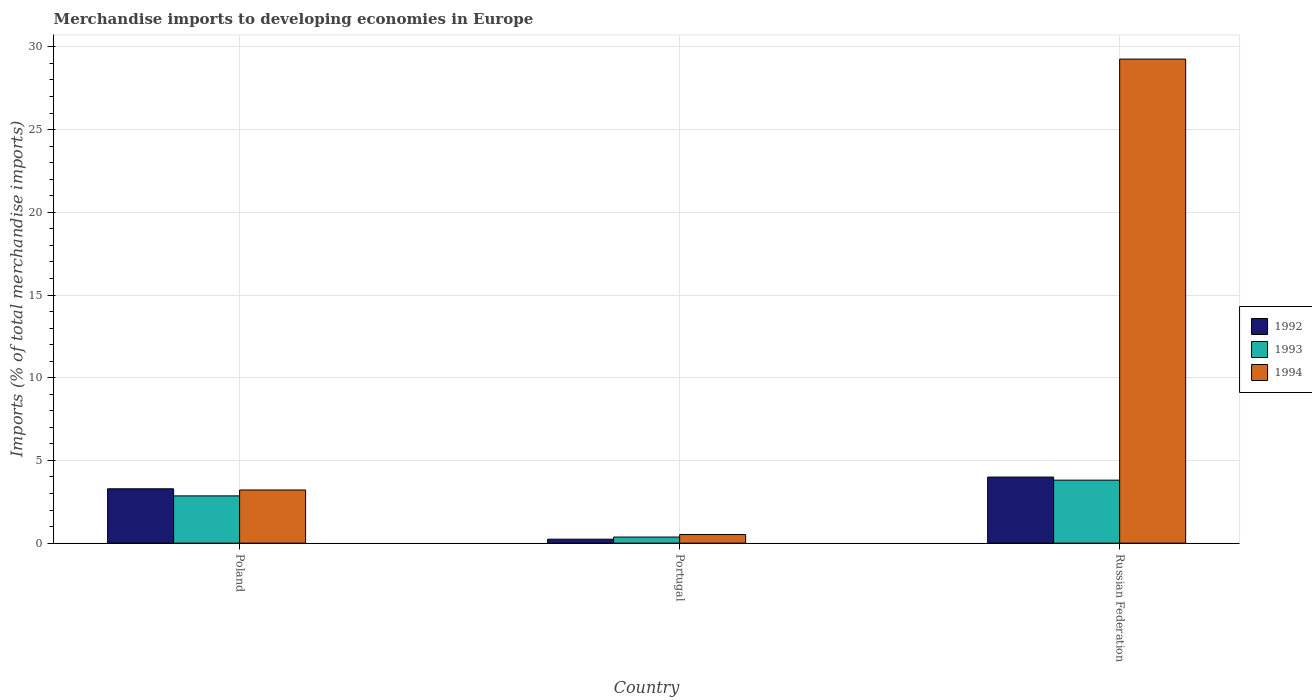How many groups of bars are there?
Give a very brief answer. 3. Are the number of bars per tick equal to the number of legend labels?
Provide a short and direct response. Yes. What is the percentage total merchandise imports in 1993 in Portugal?
Make the answer very short. 0.37. Across all countries, what is the maximum percentage total merchandise imports in 1992?
Your answer should be very brief. 4. Across all countries, what is the minimum percentage total merchandise imports in 1993?
Your answer should be very brief. 0.37. In which country was the percentage total merchandise imports in 1994 maximum?
Ensure brevity in your answer.  Russian Federation. In which country was the percentage total merchandise imports in 1992 minimum?
Make the answer very short. Portugal. What is the total percentage total merchandise imports in 1993 in the graph?
Your answer should be compact. 7.03. What is the difference between the percentage total merchandise imports in 1994 in Portugal and that in Russian Federation?
Your response must be concise. -28.74. What is the difference between the percentage total merchandise imports in 1993 in Poland and the percentage total merchandise imports in 1994 in Portugal?
Your answer should be very brief. 2.34. What is the average percentage total merchandise imports in 1994 per country?
Make the answer very short. 11. What is the difference between the percentage total merchandise imports of/in 1993 and percentage total merchandise imports of/in 1994 in Portugal?
Ensure brevity in your answer.  -0.15. In how many countries, is the percentage total merchandise imports in 1993 greater than 1 %?
Offer a terse response. 2. What is the ratio of the percentage total merchandise imports in 1992 in Portugal to that in Russian Federation?
Provide a succinct answer. 0.06. Is the difference between the percentage total merchandise imports in 1993 in Poland and Portugal greater than the difference between the percentage total merchandise imports in 1994 in Poland and Portugal?
Offer a terse response. No. What is the difference between the highest and the second highest percentage total merchandise imports in 1992?
Your answer should be very brief. -0.71. What is the difference between the highest and the lowest percentage total merchandise imports in 1992?
Your answer should be very brief. 3.76. Is the sum of the percentage total merchandise imports in 1994 in Poland and Portugal greater than the maximum percentage total merchandise imports in 1993 across all countries?
Your answer should be very brief. No. What does the 2nd bar from the right in Portugal represents?
Keep it short and to the point. 1993. Does the graph contain grids?
Offer a very short reply. Yes. How many legend labels are there?
Make the answer very short. 3. What is the title of the graph?
Your answer should be very brief. Merchandise imports to developing economies in Europe. What is the label or title of the X-axis?
Offer a terse response. Country. What is the label or title of the Y-axis?
Your answer should be very brief. Imports (% of total merchandise imports). What is the Imports (% of total merchandise imports) of 1992 in Poland?
Offer a terse response. 3.29. What is the Imports (% of total merchandise imports) in 1993 in Poland?
Ensure brevity in your answer.  2.86. What is the Imports (% of total merchandise imports) of 1994 in Poland?
Offer a terse response. 3.21. What is the Imports (% of total merchandise imports) in 1992 in Portugal?
Provide a short and direct response. 0.24. What is the Imports (% of total merchandise imports) of 1993 in Portugal?
Offer a terse response. 0.37. What is the Imports (% of total merchandise imports) of 1994 in Portugal?
Your response must be concise. 0.52. What is the Imports (% of total merchandise imports) in 1992 in Russian Federation?
Provide a succinct answer. 4. What is the Imports (% of total merchandise imports) of 1993 in Russian Federation?
Ensure brevity in your answer.  3.81. What is the Imports (% of total merchandise imports) of 1994 in Russian Federation?
Provide a succinct answer. 29.26. Across all countries, what is the maximum Imports (% of total merchandise imports) in 1992?
Provide a short and direct response. 4. Across all countries, what is the maximum Imports (% of total merchandise imports) in 1993?
Your answer should be very brief. 3.81. Across all countries, what is the maximum Imports (% of total merchandise imports) of 1994?
Give a very brief answer. 29.26. Across all countries, what is the minimum Imports (% of total merchandise imports) in 1992?
Offer a terse response. 0.24. Across all countries, what is the minimum Imports (% of total merchandise imports) in 1993?
Provide a succinct answer. 0.37. Across all countries, what is the minimum Imports (% of total merchandise imports) of 1994?
Make the answer very short. 0.52. What is the total Imports (% of total merchandise imports) in 1992 in the graph?
Give a very brief answer. 7.52. What is the total Imports (% of total merchandise imports) of 1993 in the graph?
Offer a very short reply. 7.03. What is the total Imports (% of total merchandise imports) in 1994 in the graph?
Provide a short and direct response. 33. What is the difference between the Imports (% of total merchandise imports) of 1992 in Poland and that in Portugal?
Provide a succinct answer. 3.05. What is the difference between the Imports (% of total merchandise imports) of 1993 in Poland and that in Portugal?
Give a very brief answer. 2.49. What is the difference between the Imports (% of total merchandise imports) in 1994 in Poland and that in Portugal?
Provide a succinct answer. 2.69. What is the difference between the Imports (% of total merchandise imports) of 1992 in Poland and that in Russian Federation?
Give a very brief answer. -0.71. What is the difference between the Imports (% of total merchandise imports) in 1993 in Poland and that in Russian Federation?
Your response must be concise. -0.95. What is the difference between the Imports (% of total merchandise imports) of 1994 in Poland and that in Russian Federation?
Make the answer very short. -26.05. What is the difference between the Imports (% of total merchandise imports) of 1992 in Portugal and that in Russian Federation?
Keep it short and to the point. -3.76. What is the difference between the Imports (% of total merchandise imports) in 1993 in Portugal and that in Russian Federation?
Keep it short and to the point. -3.44. What is the difference between the Imports (% of total merchandise imports) in 1994 in Portugal and that in Russian Federation?
Ensure brevity in your answer.  -28.74. What is the difference between the Imports (% of total merchandise imports) in 1992 in Poland and the Imports (% of total merchandise imports) in 1993 in Portugal?
Offer a terse response. 2.92. What is the difference between the Imports (% of total merchandise imports) in 1992 in Poland and the Imports (% of total merchandise imports) in 1994 in Portugal?
Your answer should be compact. 2.77. What is the difference between the Imports (% of total merchandise imports) of 1993 in Poland and the Imports (% of total merchandise imports) of 1994 in Portugal?
Offer a terse response. 2.34. What is the difference between the Imports (% of total merchandise imports) in 1992 in Poland and the Imports (% of total merchandise imports) in 1993 in Russian Federation?
Make the answer very short. -0.52. What is the difference between the Imports (% of total merchandise imports) of 1992 in Poland and the Imports (% of total merchandise imports) of 1994 in Russian Federation?
Offer a terse response. -25.98. What is the difference between the Imports (% of total merchandise imports) of 1993 in Poland and the Imports (% of total merchandise imports) of 1994 in Russian Federation?
Provide a short and direct response. -26.41. What is the difference between the Imports (% of total merchandise imports) of 1992 in Portugal and the Imports (% of total merchandise imports) of 1993 in Russian Federation?
Your answer should be compact. -3.57. What is the difference between the Imports (% of total merchandise imports) in 1992 in Portugal and the Imports (% of total merchandise imports) in 1994 in Russian Federation?
Offer a very short reply. -29.03. What is the difference between the Imports (% of total merchandise imports) of 1993 in Portugal and the Imports (% of total merchandise imports) of 1994 in Russian Federation?
Make the answer very short. -28.9. What is the average Imports (% of total merchandise imports) of 1992 per country?
Offer a very short reply. 2.51. What is the average Imports (% of total merchandise imports) of 1993 per country?
Offer a terse response. 2.34. What is the average Imports (% of total merchandise imports) of 1994 per country?
Provide a short and direct response. 11. What is the difference between the Imports (% of total merchandise imports) of 1992 and Imports (% of total merchandise imports) of 1993 in Poland?
Your response must be concise. 0.43. What is the difference between the Imports (% of total merchandise imports) of 1992 and Imports (% of total merchandise imports) of 1994 in Poland?
Provide a succinct answer. 0.07. What is the difference between the Imports (% of total merchandise imports) in 1993 and Imports (% of total merchandise imports) in 1994 in Poland?
Provide a short and direct response. -0.36. What is the difference between the Imports (% of total merchandise imports) of 1992 and Imports (% of total merchandise imports) of 1993 in Portugal?
Your answer should be very brief. -0.13. What is the difference between the Imports (% of total merchandise imports) of 1992 and Imports (% of total merchandise imports) of 1994 in Portugal?
Your answer should be compact. -0.28. What is the difference between the Imports (% of total merchandise imports) in 1993 and Imports (% of total merchandise imports) in 1994 in Portugal?
Ensure brevity in your answer.  -0.15. What is the difference between the Imports (% of total merchandise imports) in 1992 and Imports (% of total merchandise imports) in 1993 in Russian Federation?
Provide a succinct answer. 0.19. What is the difference between the Imports (% of total merchandise imports) of 1992 and Imports (% of total merchandise imports) of 1994 in Russian Federation?
Offer a terse response. -25.27. What is the difference between the Imports (% of total merchandise imports) of 1993 and Imports (% of total merchandise imports) of 1994 in Russian Federation?
Your answer should be compact. -25.46. What is the ratio of the Imports (% of total merchandise imports) of 1992 in Poland to that in Portugal?
Give a very brief answer. 13.77. What is the ratio of the Imports (% of total merchandise imports) in 1993 in Poland to that in Portugal?
Keep it short and to the point. 7.76. What is the ratio of the Imports (% of total merchandise imports) of 1994 in Poland to that in Portugal?
Ensure brevity in your answer.  6.17. What is the ratio of the Imports (% of total merchandise imports) in 1992 in Poland to that in Russian Federation?
Offer a terse response. 0.82. What is the ratio of the Imports (% of total merchandise imports) of 1993 in Poland to that in Russian Federation?
Provide a short and direct response. 0.75. What is the ratio of the Imports (% of total merchandise imports) of 1994 in Poland to that in Russian Federation?
Give a very brief answer. 0.11. What is the ratio of the Imports (% of total merchandise imports) in 1992 in Portugal to that in Russian Federation?
Provide a succinct answer. 0.06. What is the ratio of the Imports (% of total merchandise imports) of 1993 in Portugal to that in Russian Federation?
Provide a succinct answer. 0.1. What is the ratio of the Imports (% of total merchandise imports) of 1994 in Portugal to that in Russian Federation?
Offer a terse response. 0.02. What is the difference between the highest and the second highest Imports (% of total merchandise imports) in 1992?
Provide a short and direct response. 0.71. What is the difference between the highest and the second highest Imports (% of total merchandise imports) in 1993?
Give a very brief answer. 0.95. What is the difference between the highest and the second highest Imports (% of total merchandise imports) in 1994?
Offer a terse response. 26.05. What is the difference between the highest and the lowest Imports (% of total merchandise imports) of 1992?
Your answer should be very brief. 3.76. What is the difference between the highest and the lowest Imports (% of total merchandise imports) in 1993?
Make the answer very short. 3.44. What is the difference between the highest and the lowest Imports (% of total merchandise imports) in 1994?
Your response must be concise. 28.74. 